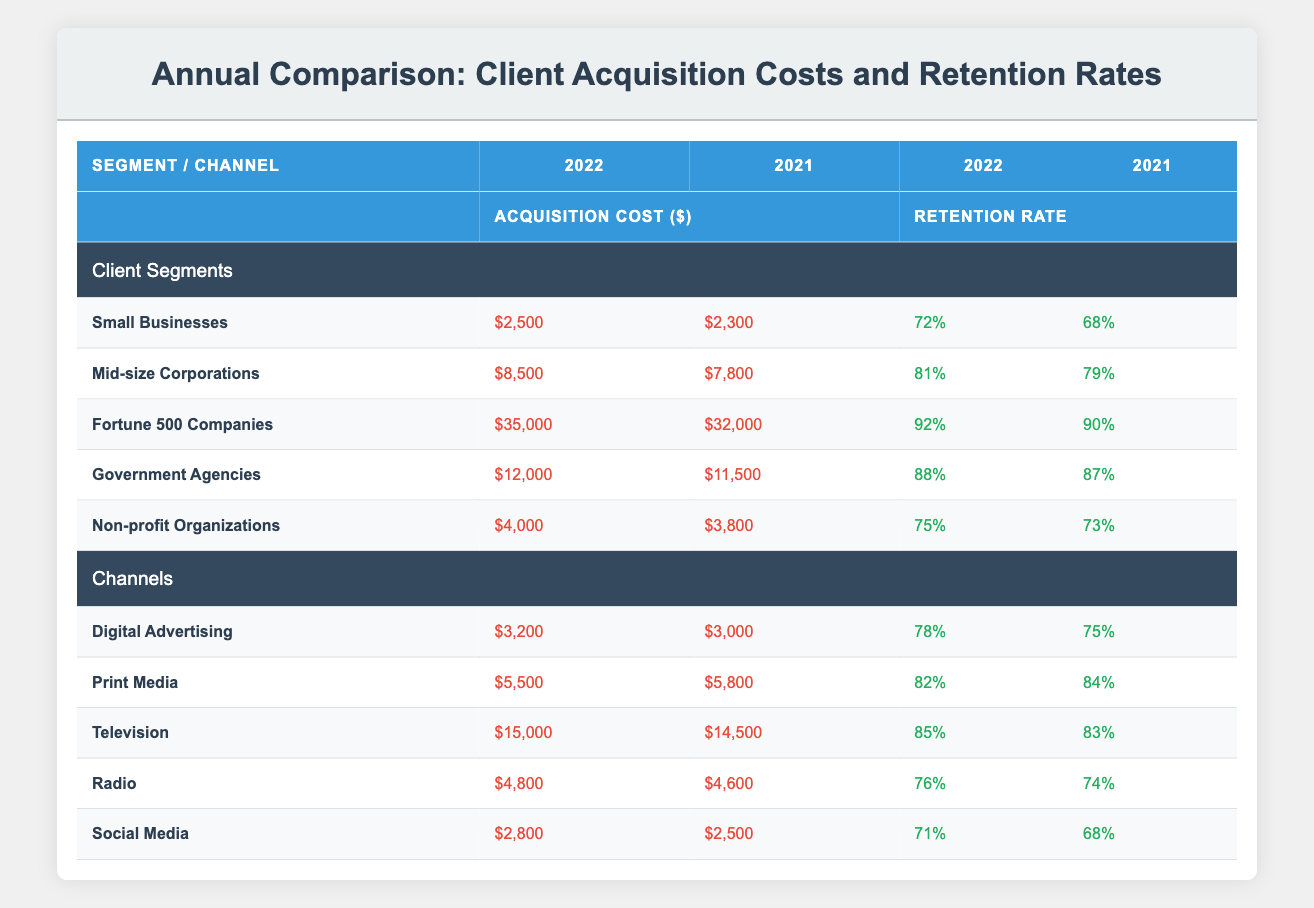What was the acquisition cost for Small Businesses in 2022? The table indicates that the acquisition cost for Small Businesses in 2022 is $2,500.
Answer: $2,500 What was the retention rate for Mid-size Corporations in 2021? According to the table, the retention rate for Mid-size Corporations in 2021 is 79%.
Answer: 79% Which client segment had the highest acquisition cost in 2022? The table shows that Fortune 500 Companies had the highest acquisition cost in 2022 at $35,000.
Answer: Fortune 500 Companies What is the increase in acquisition cost for Non-profit Organizations from 2021 to 2022? The acquisition cost for Non-profit Organizations in 2021 was $3,800 and in 2022 it is $4,000. The increase is $4,000 - $3,800 = $200.
Answer: $200 Is the retention rate for Government Agencies higher in 2022 than in 2021? Yes, the retention rate for Government Agencies is 88% in 2022, up from 87% in 2021, indicating an increase.
Answer: Yes What is the average retention rate for all client segments in 2022? The retention rates for each segment in 2022 are 72%, 81%, 92%, 88%, and 75%. To find the average: (72 + 81 + 92 + 88 + 75) / 5 = 81.6%.
Answer: 81.6% Was the acquisition cost for Television higher than that for Digital Advertising in 2022? Yes, Television's acquisition cost of $15,000 is higher than Digital Advertising's acquisition cost of $3,200 in 2022.
Answer: Yes How much more is the acquisition cost for Radio in 2022 compared to 2021? The acquisition cost for Radio in 2021 was $4,600 and in 2022 it is $4,800. The difference is $4,800 - $4,600 = $200.
Answer: $200 Which channel saw a decrease in acquisition cost from 2021 to 2022? The table shows that Print Media's acquisition cost decreased from $5,800 in 2021 to $5,500 in 2022.
Answer: Print Media 